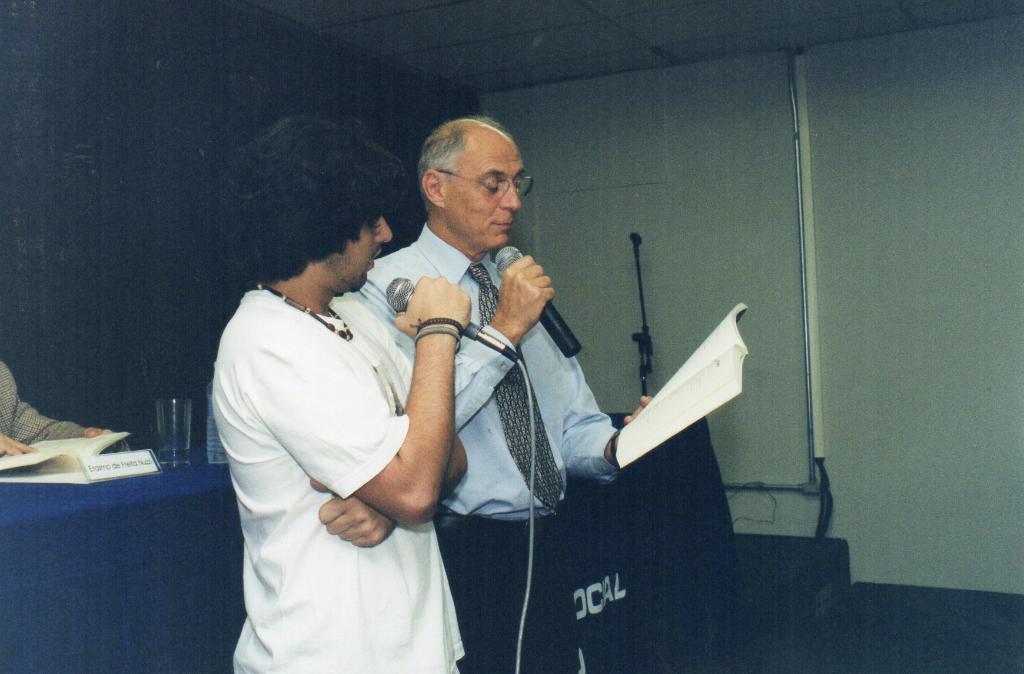How would you summarize this image in a sentence or two? In this image we can see two men are standing. One man is wearing a white color t-shirt and holding a mic in his hand. The other man is wearing a blue shirt, tie, black pant and holding a mic in one hand and a book in the other hand. We can see a table and a person in the left bottom of the image. On the table, we can see a book, name plate, glass and bottle. There is a stand in the background of the image. Behind the stand, white color wall is present. At the top of the image we can see roof. There is a blue color wall on the left side of the image. 